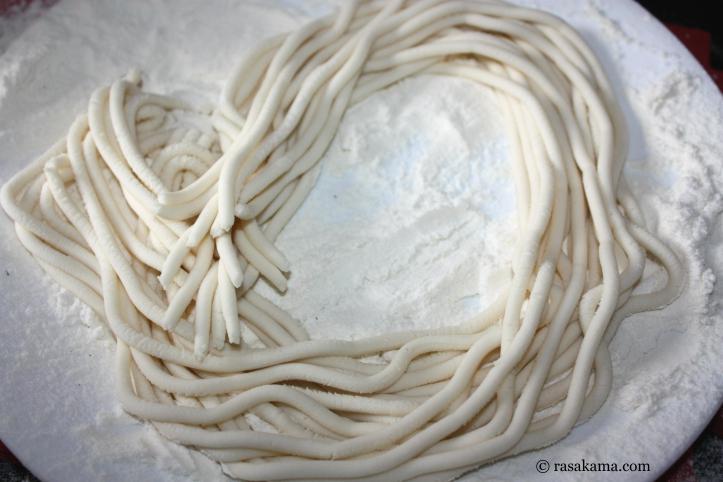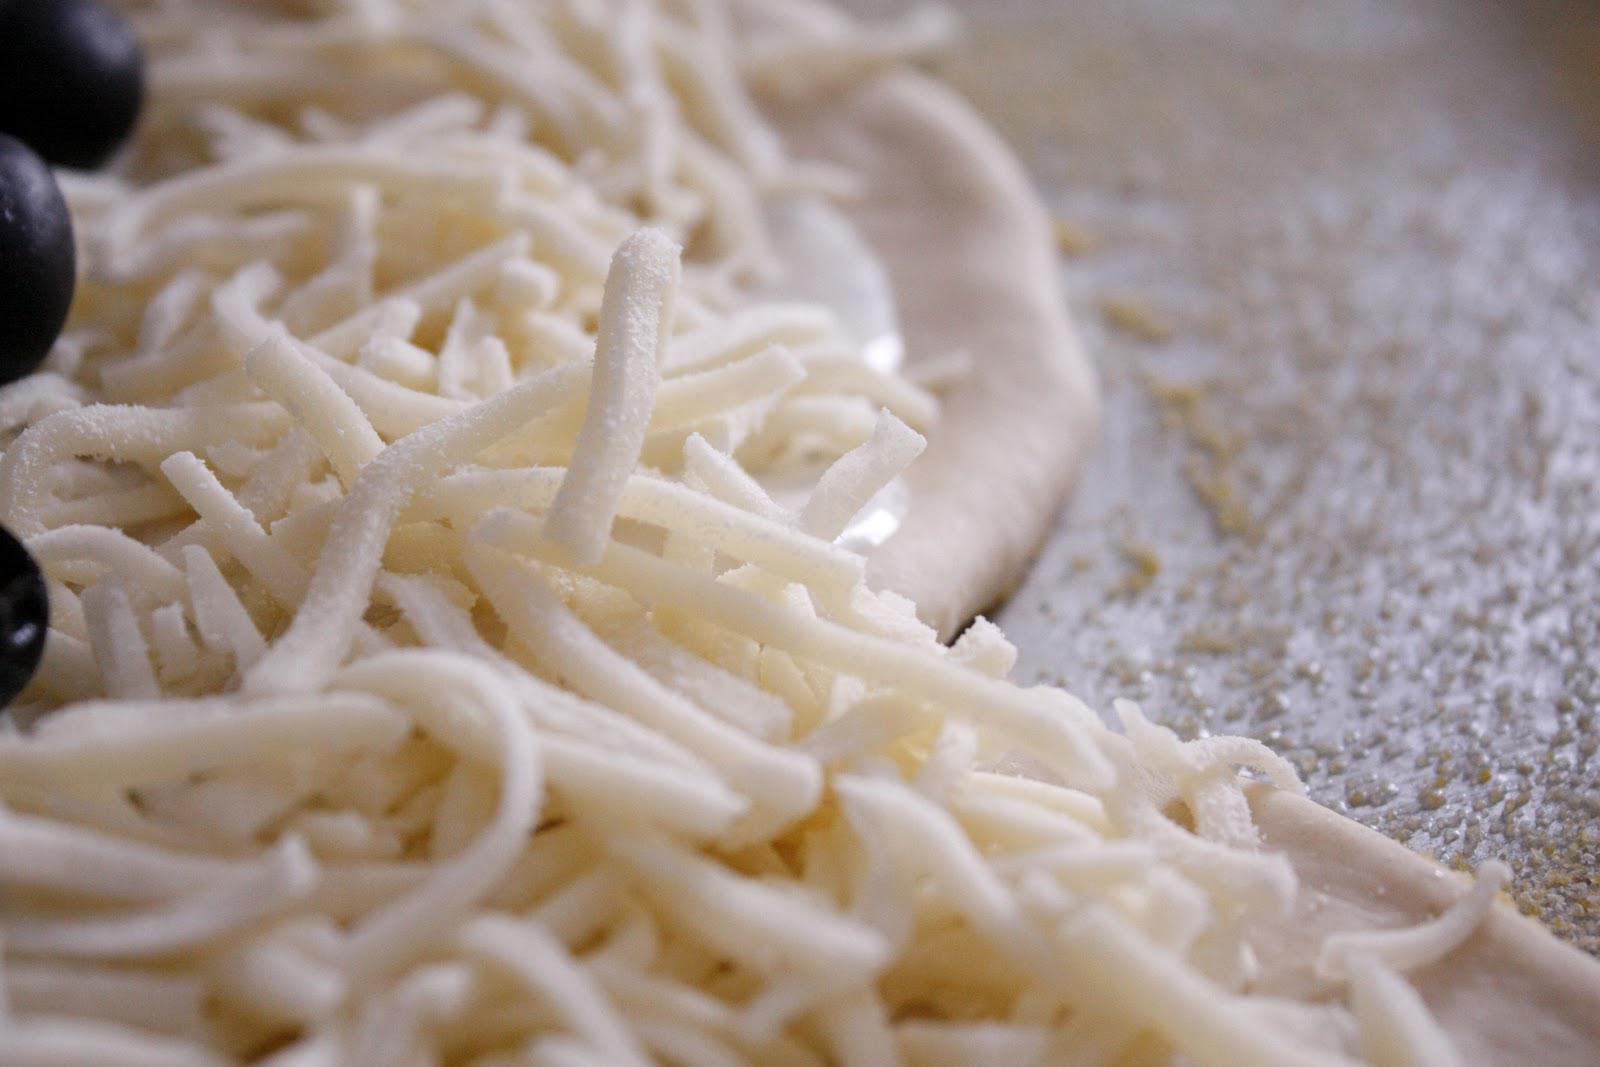The first image is the image on the left, the second image is the image on the right. Analyze the images presented: Is the assertion "The pasta in the image on the left is sitting atop a dusting of flour." valid? Answer yes or no. Yes. The first image is the image on the left, the second image is the image on the right. Evaluate the accuracy of this statement regarding the images: "There are at least 10 flat handmade noodles sitting on a wood table.". Is it true? Answer yes or no. No. 